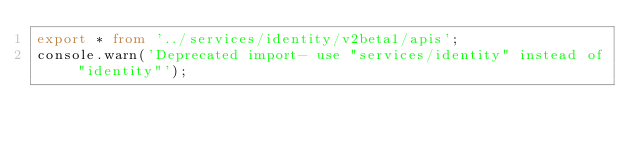Convert code to text. <code><loc_0><loc_0><loc_500><loc_500><_TypeScript_>export * from '../services/identity/v2beta1/apis';
console.warn('Deprecated import- use "services/identity" instead of "identity"');
</code> 